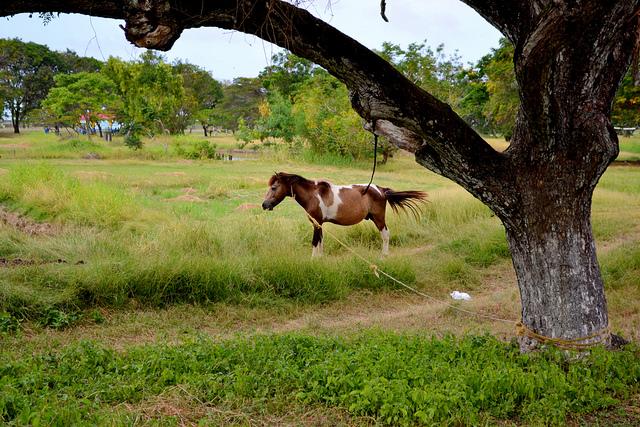Is the horse trying to eat flowers?
Write a very short answer. No. Is the horse inside a corral?
Give a very brief answer. No. Is the horse more than one color?
Short answer required. Yes. Do you see a fence?
Quick response, please. No. Is the horse tethered?
Concise answer only. Yes. How many trees are in the foreground?
Give a very brief answer. 1. What is the horse doing with its mouth?
Write a very short answer. Eating. 